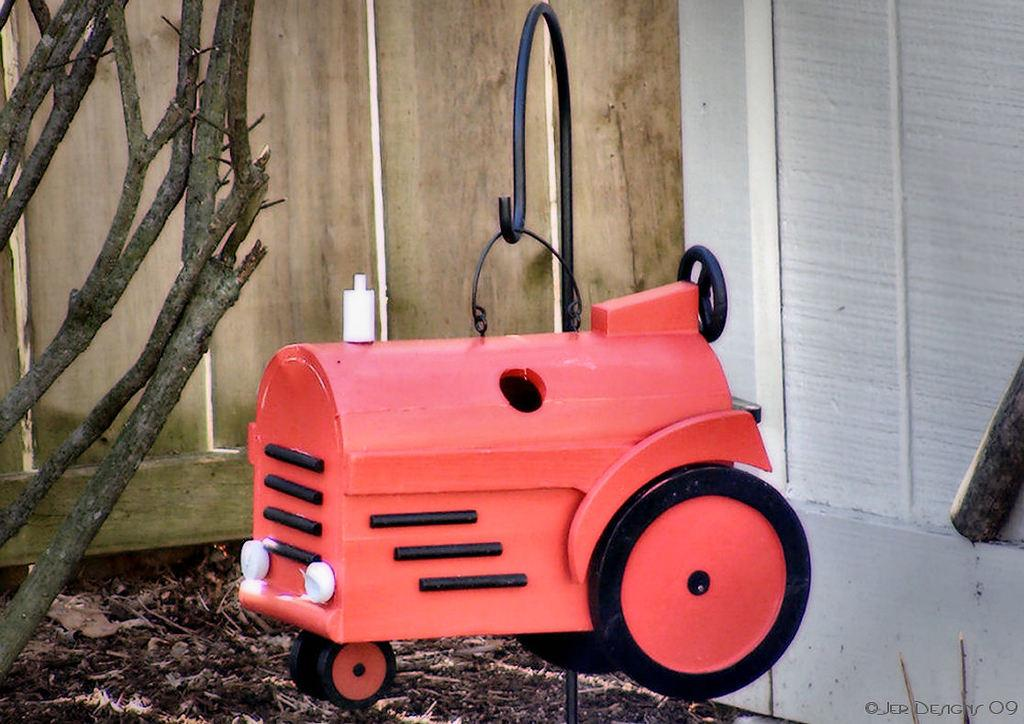What type of vehicle is in the image? There is a small red color vehicle in the image. Where is the vehicle located? The vehicle is on the ground. What can be seen on the left side of the image? There are wooden sticks on the left side of the image. What is visible in the background of the image? There is a wooden wall in the background of the image. What type of amusement can be seen in the image? There is no amusement present in the image; it features a small red color vehicle, wooden sticks, and a wooden wall in the background. How many clovers are visible in the image? There are no clovers present in the image. 